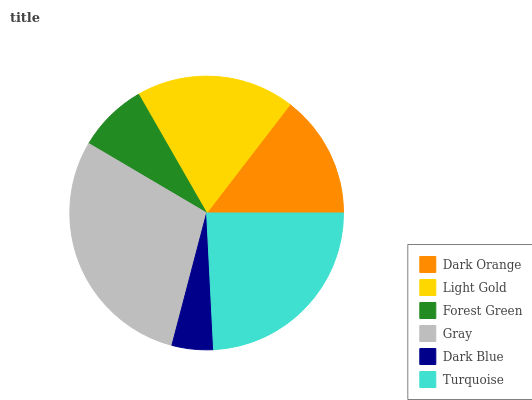Is Dark Blue the minimum?
Answer yes or no. Yes. Is Gray the maximum?
Answer yes or no. Yes. Is Light Gold the minimum?
Answer yes or no. No. Is Light Gold the maximum?
Answer yes or no. No. Is Light Gold greater than Dark Orange?
Answer yes or no. Yes. Is Dark Orange less than Light Gold?
Answer yes or no. Yes. Is Dark Orange greater than Light Gold?
Answer yes or no. No. Is Light Gold less than Dark Orange?
Answer yes or no. No. Is Light Gold the high median?
Answer yes or no. Yes. Is Dark Orange the low median?
Answer yes or no. Yes. Is Dark Blue the high median?
Answer yes or no. No. Is Dark Blue the low median?
Answer yes or no. No. 